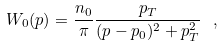<formula> <loc_0><loc_0><loc_500><loc_500>W _ { 0 } ( p ) = \frac { n _ { 0 } } { \pi } \frac { p _ { T } } { ( p - p _ { 0 } ) ^ { 2 } + p _ { T } ^ { 2 } } \ ,</formula> 